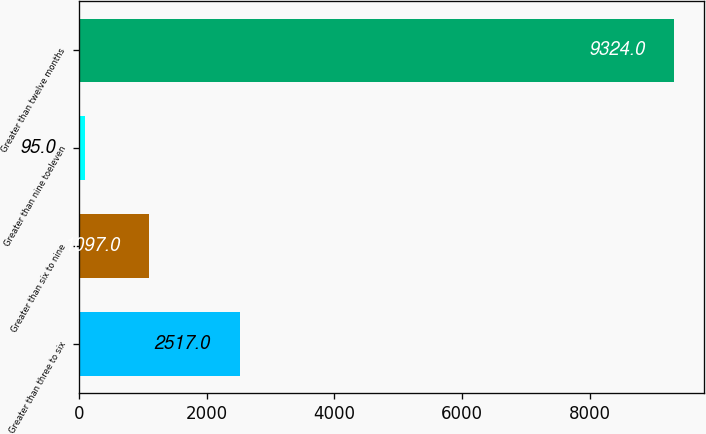<chart> <loc_0><loc_0><loc_500><loc_500><bar_chart><fcel>Greater than three to six<fcel>Greater than six to nine<fcel>Greater than nine toeleven<fcel>Greater than twelve months<nl><fcel>2517<fcel>1097<fcel>95<fcel>9324<nl></chart> 